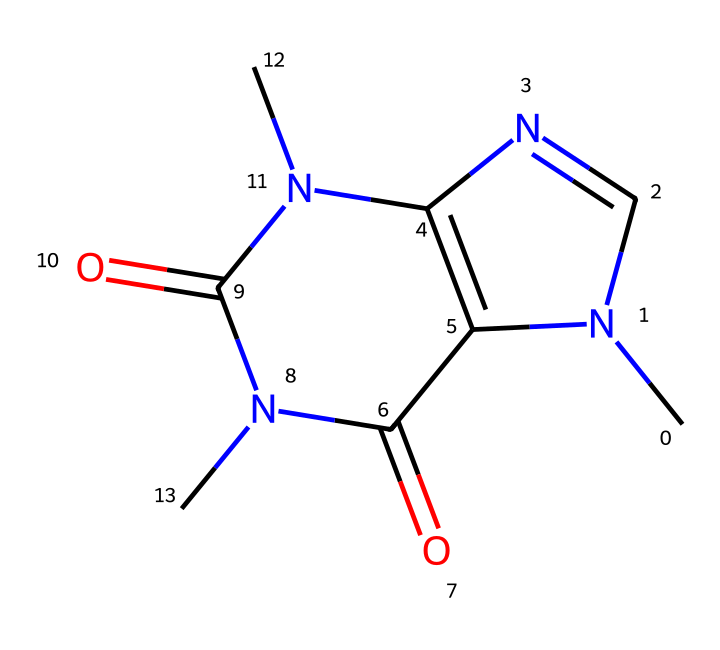What is the molecular formula of caffeine? To find the molecular formula, count the number of carbon (C), hydrogen (H), nitrogen (N), and oxygen (O) atoms in the structure. In this SMILES, there are 8 carbons, 10 hydrogens, 4 nitrogens, and 2 oxygens, leading to the formula C8H10N4O2.
Answer: C8H10N4O2 How many chiral centers are present in caffeine? Analyze the structure for any carbon atoms that are attached to four different substituents, which indicates chirality. In caffeine, there is one carbon atom that meets this criterion, indicating the presence of one chiral center.
Answer: 1 What type of compound is caffeine classified as? Examine the functional groups and the overall structure. Caffeine is considered an alkaloid due to its nitrogen-containing structure and psychoactive properties.
Answer: alkaloid What is the total number of rings in the caffeine molecule? Inspect the structure for any cyclic components. Caffeine contains two fused rings, confirming that it has a total of two rings.
Answer: 2 Does caffeine have any functional groups? Look for specific characteristic groups within the structure. Caffeine has amine and carbonyl functional groups, identifiable by the specific arrangements of nitrogen and oxygen atoms in the molecular structure.
Answer: amine and carbonyl How many double bonds are present in the caffeine structure? Examine the structure to identify the presence of double bonds; they can be seen between certain carbon and nitrogen atoms. In caffeine, there are three double bonds present, indicating considerable unsaturation.
Answer: 3 